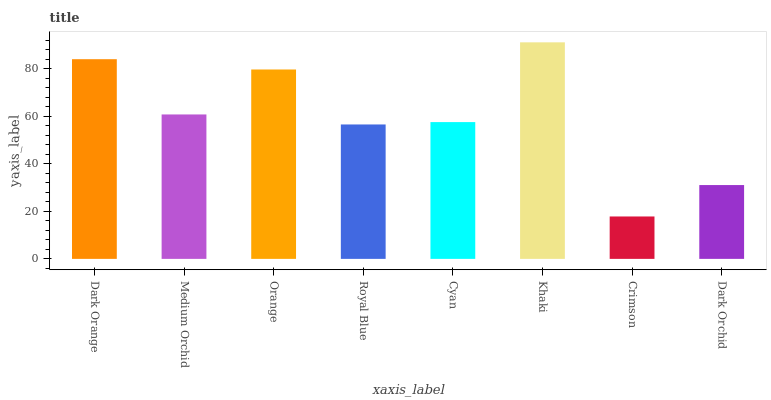Is Crimson the minimum?
Answer yes or no. Yes. Is Khaki the maximum?
Answer yes or no. Yes. Is Medium Orchid the minimum?
Answer yes or no. No. Is Medium Orchid the maximum?
Answer yes or no. No. Is Dark Orange greater than Medium Orchid?
Answer yes or no. Yes. Is Medium Orchid less than Dark Orange?
Answer yes or no. Yes. Is Medium Orchid greater than Dark Orange?
Answer yes or no. No. Is Dark Orange less than Medium Orchid?
Answer yes or no. No. Is Medium Orchid the high median?
Answer yes or no. Yes. Is Cyan the low median?
Answer yes or no. Yes. Is Cyan the high median?
Answer yes or no. No. Is Royal Blue the low median?
Answer yes or no. No. 